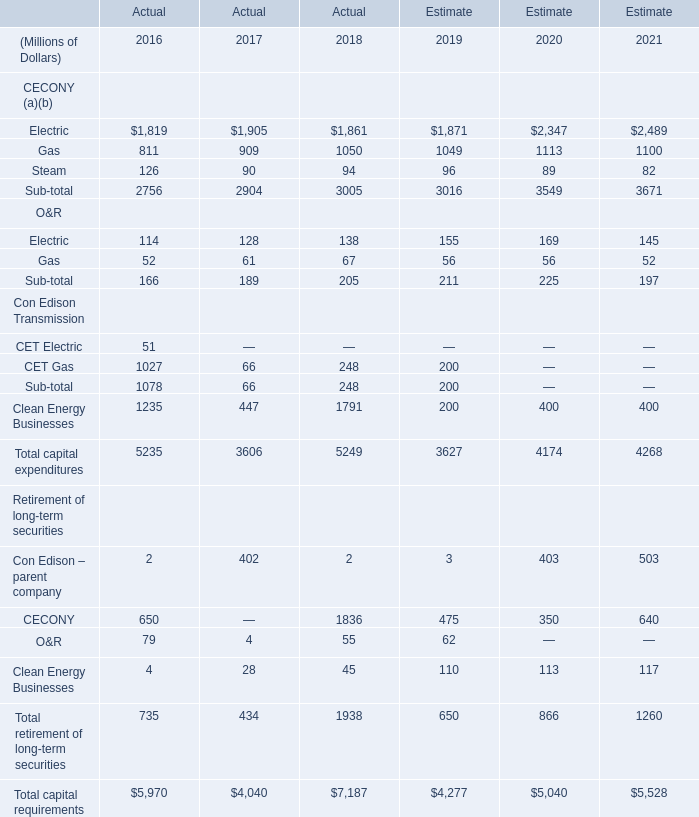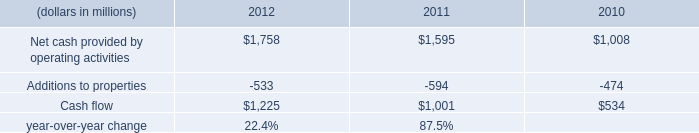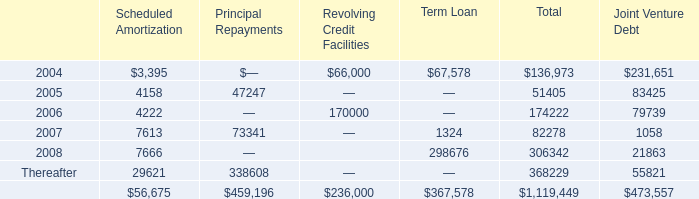What is the average amount of CET Gas Con Edison Transmission of Actual 2016, and Net cash provided by operating activities of 2011 ? 
Computations: ((1027.0 + 1595.0) / 2)
Answer: 1311.0. 